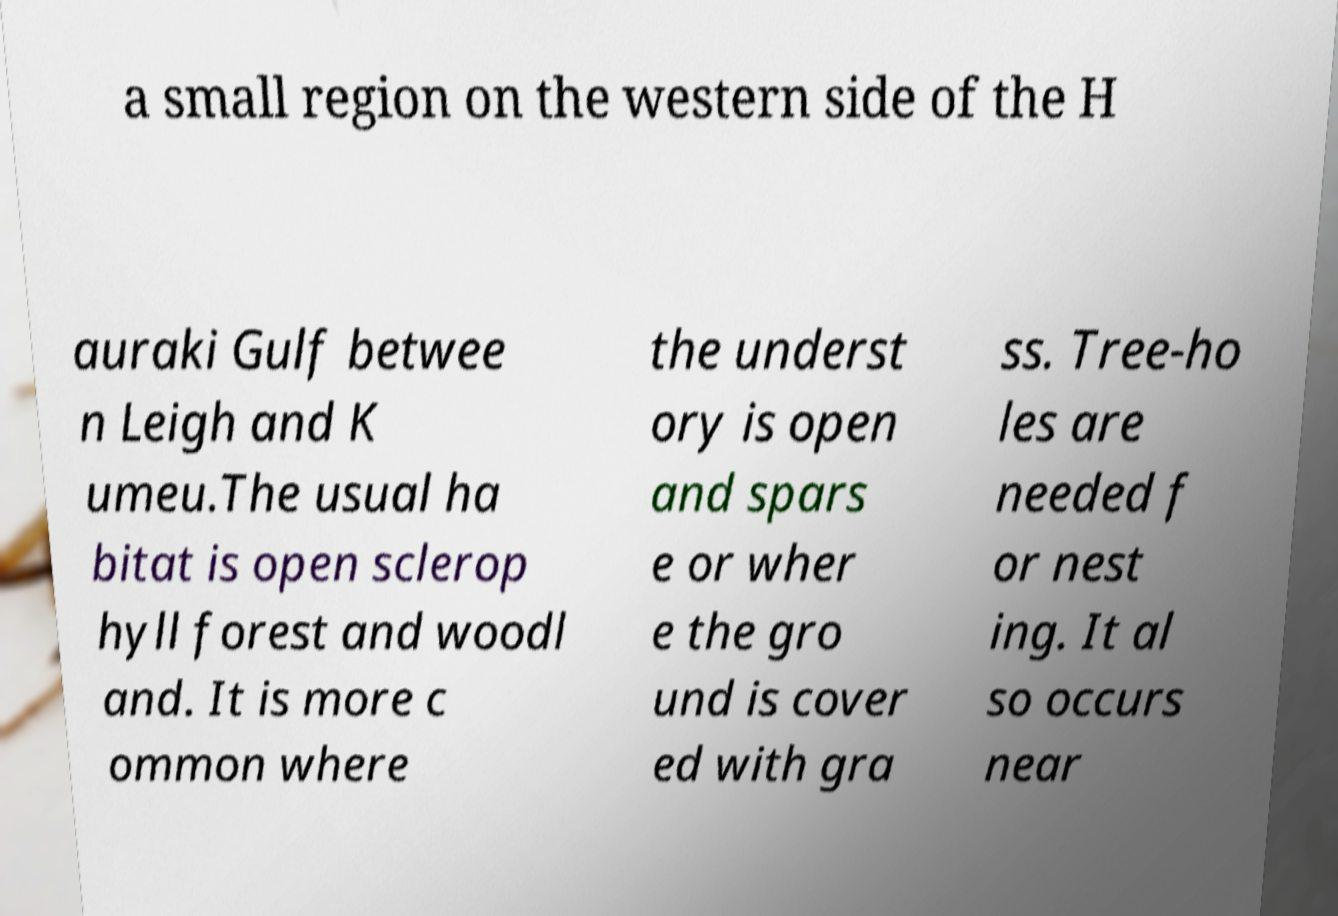Can you accurately transcribe the text from the provided image for me? a small region on the western side of the H auraki Gulf betwee n Leigh and K umeu.The usual ha bitat is open sclerop hyll forest and woodl and. It is more c ommon where the underst ory is open and spars e or wher e the gro und is cover ed with gra ss. Tree-ho les are needed f or nest ing. It al so occurs near 